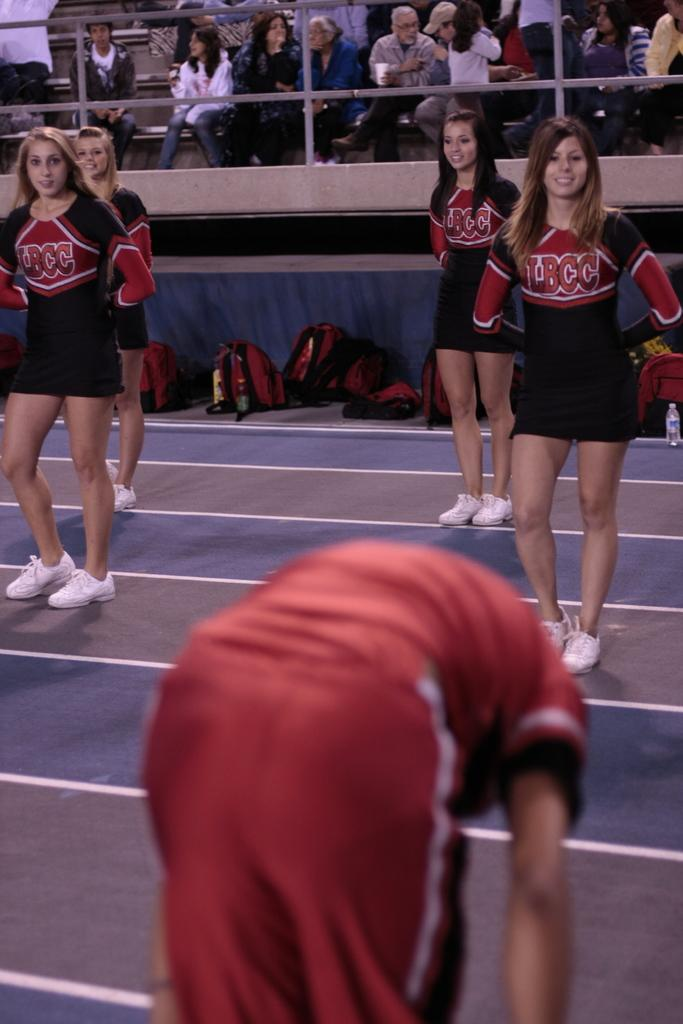What is the main setting of the image? The main setting of the image is a stadium. What are the people in the stadium doing? Many people are sitting in the stadium. Are there any objects on the ground in the image? Yes, there are objects placed on the ground. Can you describe the position of some people in the image? There are few people standing in the image. What type of cabbage is being used as a seat cushion in the image? There is no cabbage present in the image, and therefore it cannot be used as a seat cushion. Can you tell me how many porters are assisting the people in the image? There is no mention of porters in the image, so it is impossible to determine their presence or number. 